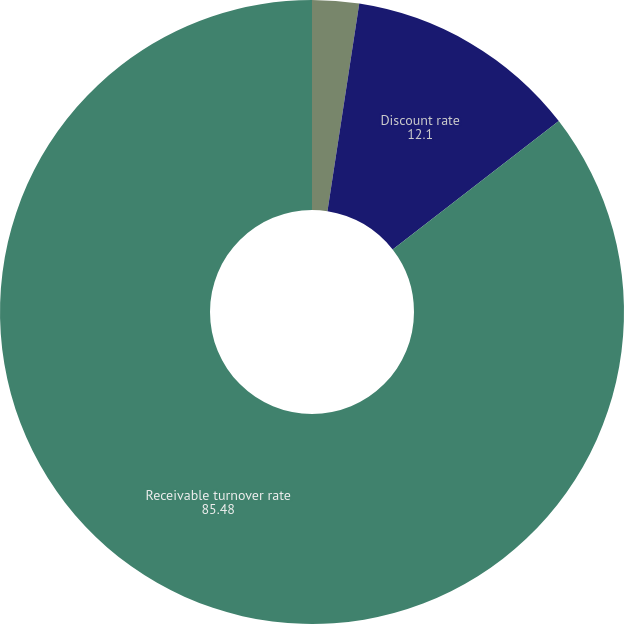<chart> <loc_0><loc_0><loc_500><loc_500><pie_chart><fcel>Anticipated credit loss ratio<fcel>Discount rate<fcel>Receivable turnover rate<nl><fcel>2.42%<fcel>12.1%<fcel>85.48%<nl></chart> 